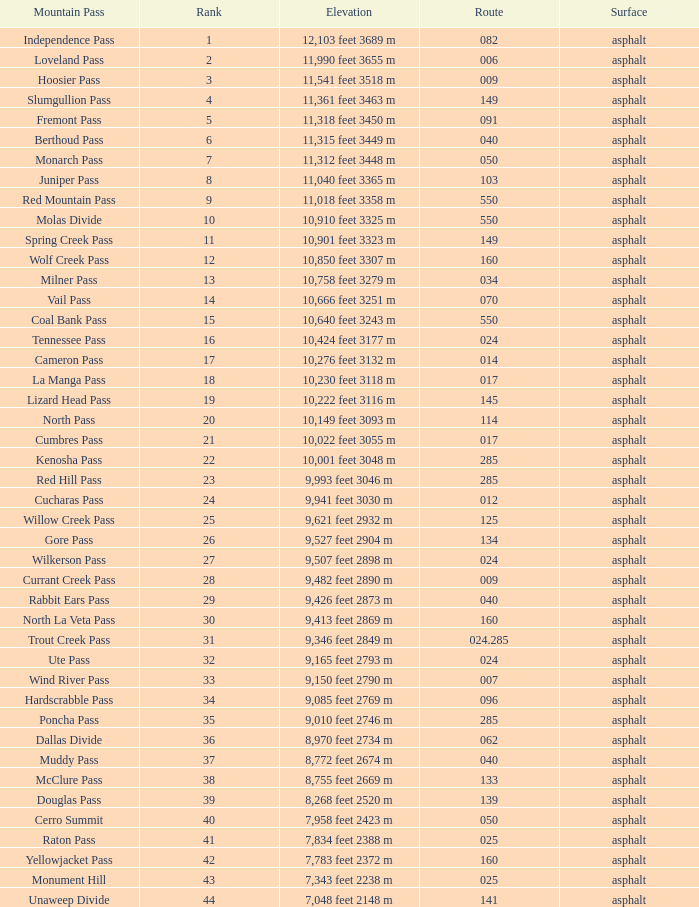What is the Elevation of the mountain on Route 62? 8,970 feet 2734 m. 